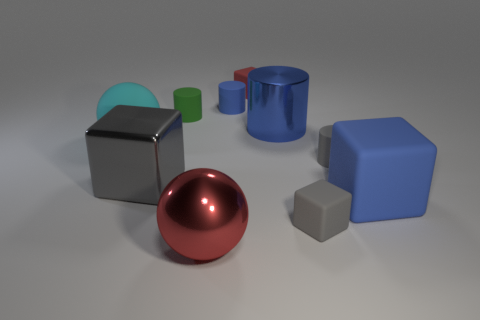Subtract all matte cylinders. How many cylinders are left? 1 Subtract all cylinders. How many objects are left? 6 Subtract 2 cubes. How many cubes are left? 2 Subtract all yellow spheres. How many blue cylinders are left? 2 Subtract all gray cylinders. How many cylinders are left? 3 Subtract 0 purple balls. How many objects are left? 10 Subtract all purple spheres. Subtract all gray blocks. How many spheres are left? 2 Subtract all small blue matte things. Subtract all small rubber cylinders. How many objects are left? 6 Add 4 tiny green matte cylinders. How many tiny green matte cylinders are left? 5 Add 5 large cyan things. How many large cyan things exist? 6 